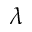<formula> <loc_0><loc_0><loc_500><loc_500>\lambda</formula> 